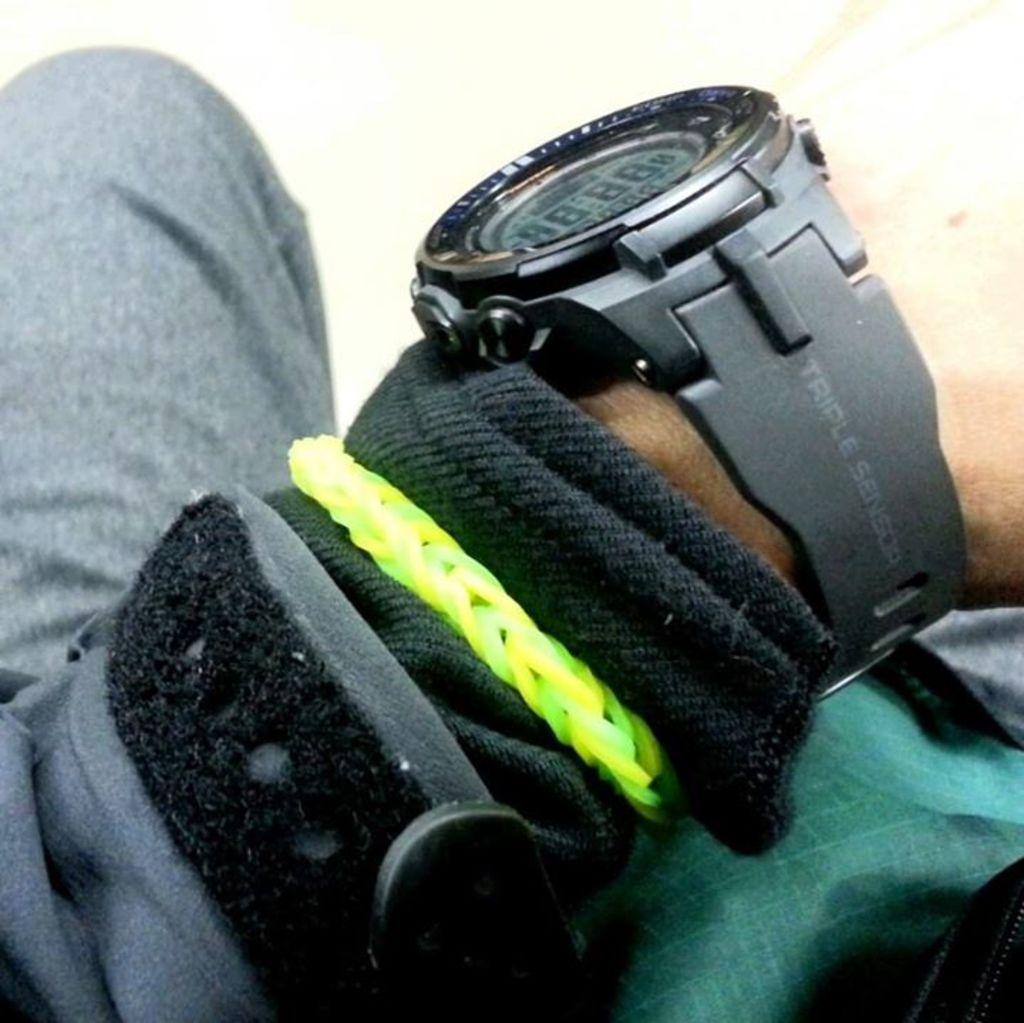How many sensors does that watch have?
Provide a short and direct response. 3. 